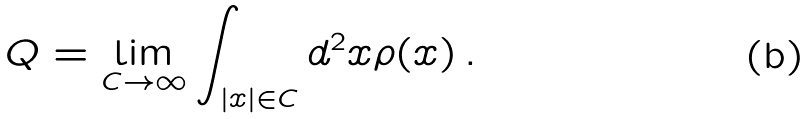Convert formula to latex. <formula><loc_0><loc_0><loc_500><loc_500>Q = \lim _ { C \to \infty } \int _ { | x | \in C } d ^ { 2 } x \rho ( x ) \, .</formula> 